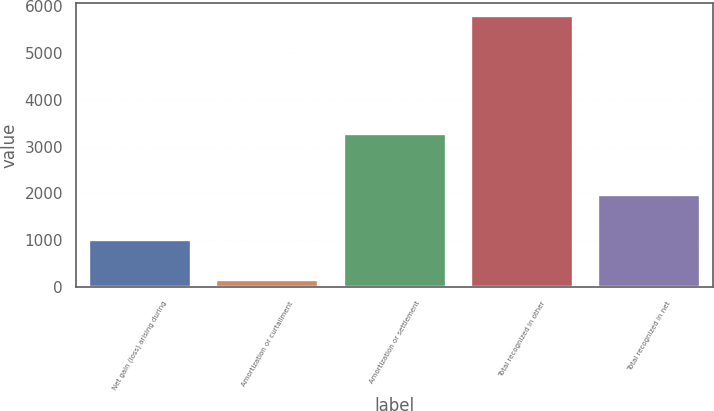Convert chart. <chart><loc_0><loc_0><loc_500><loc_500><bar_chart><fcel>Net gain (loss) arising during<fcel>Amortization or curtailment<fcel>Amortization or settlement<fcel>Total recognized in other<fcel>Total recognized in net<nl><fcel>996<fcel>144<fcel>3275<fcel>5786<fcel>1963<nl></chart> 